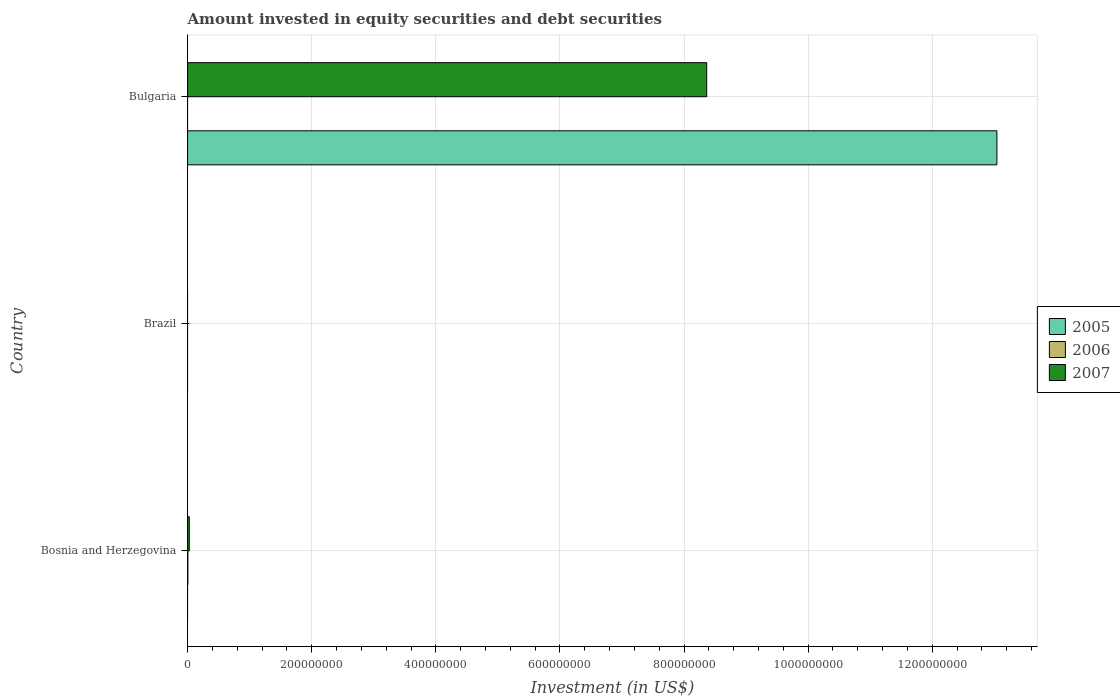How many different coloured bars are there?
Provide a short and direct response. 3. Are the number of bars per tick equal to the number of legend labels?
Your answer should be very brief. No. How many bars are there on the 1st tick from the top?
Provide a short and direct response. 2. How many bars are there on the 1st tick from the bottom?
Provide a short and direct response. 2. What is the label of the 1st group of bars from the top?
Your answer should be compact. Bulgaria. In how many cases, is the number of bars for a given country not equal to the number of legend labels?
Make the answer very short. 3. Across all countries, what is the maximum amount invested in equity securities and debt securities in 2007?
Offer a very short reply. 8.37e+08. What is the total amount invested in equity securities and debt securities in 2006 in the graph?
Your answer should be compact. 3.88e+05. What is the difference between the amount invested in equity securities and debt securities in 2007 in Bosnia and Herzegovina and that in Bulgaria?
Provide a short and direct response. -8.34e+08. What is the difference between the amount invested in equity securities and debt securities in 2007 in Brazil and the amount invested in equity securities and debt securities in 2005 in Bulgaria?
Your response must be concise. -1.30e+09. What is the average amount invested in equity securities and debt securities in 2006 per country?
Offer a very short reply. 1.29e+05. What is the difference between the amount invested in equity securities and debt securities in 2007 and amount invested in equity securities and debt securities in 2006 in Bosnia and Herzegovina?
Give a very brief answer. 2.31e+06. In how many countries, is the amount invested in equity securities and debt securities in 2005 greater than 640000000 US$?
Provide a succinct answer. 1. What is the ratio of the amount invested in equity securities and debt securities in 2007 in Bosnia and Herzegovina to that in Bulgaria?
Keep it short and to the point. 0. What is the difference between the highest and the lowest amount invested in equity securities and debt securities in 2005?
Keep it short and to the point. 1.30e+09. How many bars are there?
Your answer should be compact. 4. Are all the bars in the graph horizontal?
Give a very brief answer. Yes. What is the difference between two consecutive major ticks on the X-axis?
Give a very brief answer. 2.00e+08. Are the values on the major ticks of X-axis written in scientific E-notation?
Offer a very short reply. No. Does the graph contain grids?
Offer a terse response. Yes. Where does the legend appear in the graph?
Offer a terse response. Center right. How many legend labels are there?
Provide a succinct answer. 3. What is the title of the graph?
Offer a terse response. Amount invested in equity securities and debt securities. What is the label or title of the X-axis?
Ensure brevity in your answer.  Investment (in US$). What is the Investment (in US$) of 2005 in Bosnia and Herzegovina?
Offer a terse response. 0. What is the Investment (in US$) of 2006 in Bosnia and Herzegovina?
Your response must be concise. 3.88e+05. What is the Investment (in US$) in 2007 in Bosnia and Herzegovina?
Keep it short and to the point. 2.70e+06. What is the Investment (in US$) of 2005 in Brazil?
Keep it short and to the point. 0. What is the Investment (in US$) of 2005 in Bulgaria?
Ensure brevity in your answer.  1.30e+09. What is the Investment (in US$) in 2007 in Bulgaria?
Offer a very short reply. 8.37e+08. Across all countries, what is the maximum Investment (in US$) of 2005?
Offer a very short reply. 1.30e+09. Across all countries, what is the maximum Investment (in US$) in 2006?
Offer a very short reply. 3.88e+05. Across all countries, what is the maximum Investment (in US$) in 2007?
Your response must be concise. 8.37e+08. Across all countries, what is the minimum Investment (in US$) of 2007?
Offer a very short reply. 0. What is the total Investment (in US$) in 2005 in the graph?
Give a very brief answer. 1.30e+09. What is the total Investment (in US$) of 2006 in the graph?
Provide a short and direct response. 3.88e+05. What is the total Investment (in US$) of 2007 in the graph?
Offer a terse response. 8.39e+08. What is the difference between the Investment (in US$) in 2007 in Bosnia and Herzegovina and that in Bulgaria?
Your answer should be compact. -8.34e+08. What is the difference between the Investment (in US$) of 2006 in Bosnia and Herzegovina and the Investment (in US$) of 2007 in Bulgaria?
Give a very brief answer. -8.36e+08. What is the average Investment (in US$) of 2005 per country?
Keep it short and to the point. 4.35e+08. What is the average Investment (in US$) in 2006 per country?
Make the answer very short. 1.29e+05. What is the average Investment (in US$) of 2007 per country?
Keep it short and to the point. 2.80e+08. What is the difference between the Investment (in US$) in 2006 and Investment (in US$) in 2007 in Bosnia and Herzegovina?
Make the answer very short. -2.31e+06. What is the difference between the Investment (in US$) of 2005 and Investment (in US$) of 2007 in Bulgaria?
Your answer should be compact. 4.68e+08. What is the ratio of the Investment (in US$) of 2007 in Bosnia and Herzegovina to that in Bulgaria?
Offer a very short reply. 0. What is the difference between the highest and the lowest Investment (in US$) of 2005?
Your response must be concise. 1.30e+09. What is the difference between the highest and the lowest Investment (in US$) of 2006?
Offer a terse response. 3.88e+05. What is the difference between the highest and the lowest Investment (in US$) in 2007?
Keep it short and to the point. 8.37e+08. 